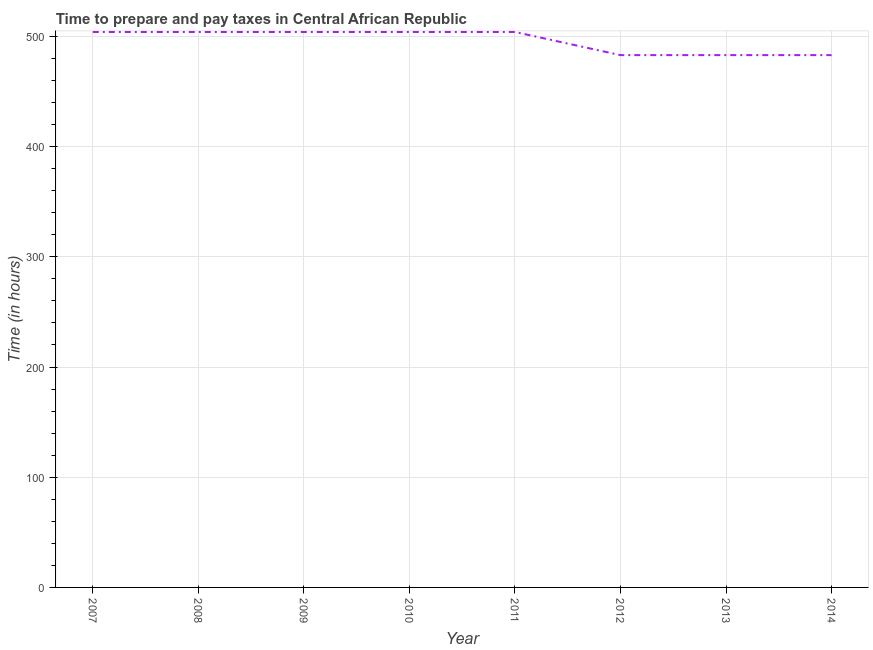What is the time to prepare and pay taxes in 2008?
Give a very brief answer. 504. Across all years, what is the maximum time to prepare and pay taxes?
Give a very brief answer. 504. Across all years, what is the minimum time to prepare and pay taxes?
Provide a succinct answer. 483. In which year was the time to prepare and pay taxes maximum?
Your answer should be very brief. 2007. In which year was the time to prepare and pay taxes minimum?
Your answer should be compact. 2012. What is the sum of the time to prepare and pay taxes?
Provide a short and direct response. 3969. What is the difference between the time to prepare and pay taxes in 2007 and 2008?
Provide a succinct answer. 0. What is the average time to prepare and pay taxes per year?
Your response must be concise. 496.12. What is the median time to prepare and pay taxes?
Make the answer very short. 504. In how many years, is the time to prepare and pay taxes greater than 160 hours?
Provide a succinct answer. 8. Do a majority of the years between 2013 and 2014 (inclusive) have time to prepare and pay taxes greater than 460 hours?
Ensure brevity in your answer.  Yes. What is the ratio of the time to prepare and pay taxes in 2009 to that in 2012?
Your answer should be very brief. 1.04. Is the time to prepare and pay taxes in 2012 less than that in 2013?
Make the answer very short. No. Is the difference between the time to prepare and pay taxes in 2008 and 2014 greater than the difference between any two years?
Make the answer very short. Yes. Is the sum of the time to prepare and pay taxes in 2011 and 2013 greater than the maximum time to prepare and pay taxes across all years?
Provide a short and direct response. Yes. What is the difference between the highest and the lowest time to prepare and pay taxes?
Provide a short and direct response. 21. Does the time to prepare and pay taxes monotonically increase over the years?
Provide a short and direct response. No. How many years are there in the graph?
Make the answer very short. 8. What is the difference between two consecutive major ticks on the Y-axis?
Your response must be concise. 100. Are the values on the major ticks of Y-axis written in scientific E-notation?
Offer a terse response. No. Does the graph contain any zero values?
Keep it short and to the point. No. What is the title of the graph?
Offer a terse response. Time to prepare and pay taxes in Central African Republic. What is the label or title of the Y-axis?
Your response must be concise. Time (in hours). What is the Time (in hours) of 2007?
Ensure brevity in your answer.  504. What is the Time (in hours) of 2008?
Your answer should be very brief. 504. What is the Time (in hours) of 2009?
Your answer should be very brief. 504. What is the Time (in hours) of 2010?
Keep it short and to the point. 504. What is the Time (in hours) of 2011?
Keep it short and to the point. 504. What is the Time (in hours) in 2012?
Ensure brevity in your answer.  483. What is the Time (in hours) of 2013?
Your response must be concise. 483. What is the Time (in hours) of 2014?
Your answer should be compact. 483. What is the difference between the Time (in hours) in 2007 and 2009?
Provide a succinct answer. 0. What is the difference between the Time (in hours) in 2007 and 2012?
Your response must be concise. 21. What is the difference between the Time (in hours) in 2007 and 2013?
Provide a short and direct response. 21. What is the difference between the Time (in hours) in 2007 and 2014?
Give a very brief answer. 21. What is the difference between the Time (in hours) in 2008 and 2009?
Ensure brevity in your answer.  0. What is the difference between the Time (in hours) in 2008 and 2011?
Ensure brevity in your answer.  0. What is the difference between the Time (in hours) in 2008 and 2014?
Offer a very short reply. 21. What is the difference between the Time (in hours) in 2009 and 2011?
Ensure brevity in your answer.  0. What is the difference between the Time (in hours) in 2009 and 2014?
Give a very brief answer. 21. What is the difference between the Time (in hours) in 2010 and 2012?
Offer a terse response. 21. What is the difference between the Time (in hours) in 2011 and 2012?
Give a very brief answer. 21. What is the difference between the Time (in hours) in 2011 and 2014?
Provide a short and direct response. 21. What is the difference between the Time (in hours) in 2012 and 2014?
Ensure brevity in your answer.  0. What is the difference between the Time (in hours) in 2013 and 2014?
Offer a very short reply. 0. What is the ratio of the Time (in hours) in 2007 to that in 2012?
Provide a succinct answer. 1.04. What is the ratio of the Time (in hours) in 2007 to that in 2013?
Offer a terse response. 1.04. What is the ratio of the Time (in hours) in 2007 to that in 2014?
Your answer should be very brief. 1.04. What is the ratio of the Time (in hours) in 2008 to that in 2009?
Provide a succinct answer. 1. What is the ratio of the Time (in hours) in 2008 to that in 2010?
Make the answer very short. 1. What is the ratio of the Time (in hours) in 2008 to that in 2011?
Make the answer very short. 1. What is the ratio of the Time (in hours) in 2008 to that in 2012?
Offer a terse response. 1.04. What is the ratio of the Time (in hours) in 2008 to that in 2013?
Make the answer very short. 1.04. What is the ratio of the Time (in hours) in 2008 to that in 2014?
Offer a terse response. 1.04. What is the ratio of the Time (in hours) in 2009 to that in 2011?
Your answer should be compact. 1. What is the ratio of the Time (in hours) in 2009 to that in 2012?
Your answer should be compact. 1.04. What is the ratio of the Time (in hours) in 2009 to that in 2013?
Offer a very short reply. 1.04. What is the ratio of the Time (in hours) in 2009 to that in 2014?
Your answer should be very brief. 1.04. What is the ratio of the Time (in hours) in 2010 to that in 2012?
Ensure brevity in your answer.  1.04. What is the ratio of the Time (in hours) in 2010 to that in 2013?
Make the answer very short. 1.04. What is the ratio of the Time (in hours) in 2010 to that in 2014?
Make the answer very short. 1.04. What is the ratio of the Time (in hours) in 2011 to that in 2012?
Make the answer very short. 1.04. What is the ratio of the Time (in hours) in 2011 to that in 2013?
Keep it short and to the point. 1.04. What is the ratio of the Time (in hours) in 2011 to that in 2014?
Ensure brevity in your answer.  1.04. What is the ratio of the Time (in hours) in 2012 to that in 2014?
Your answer should be very brief. 1. What is the ratio of the Time (in hours) in 2013 to that in 2014?
Your response must be concise. 1. 